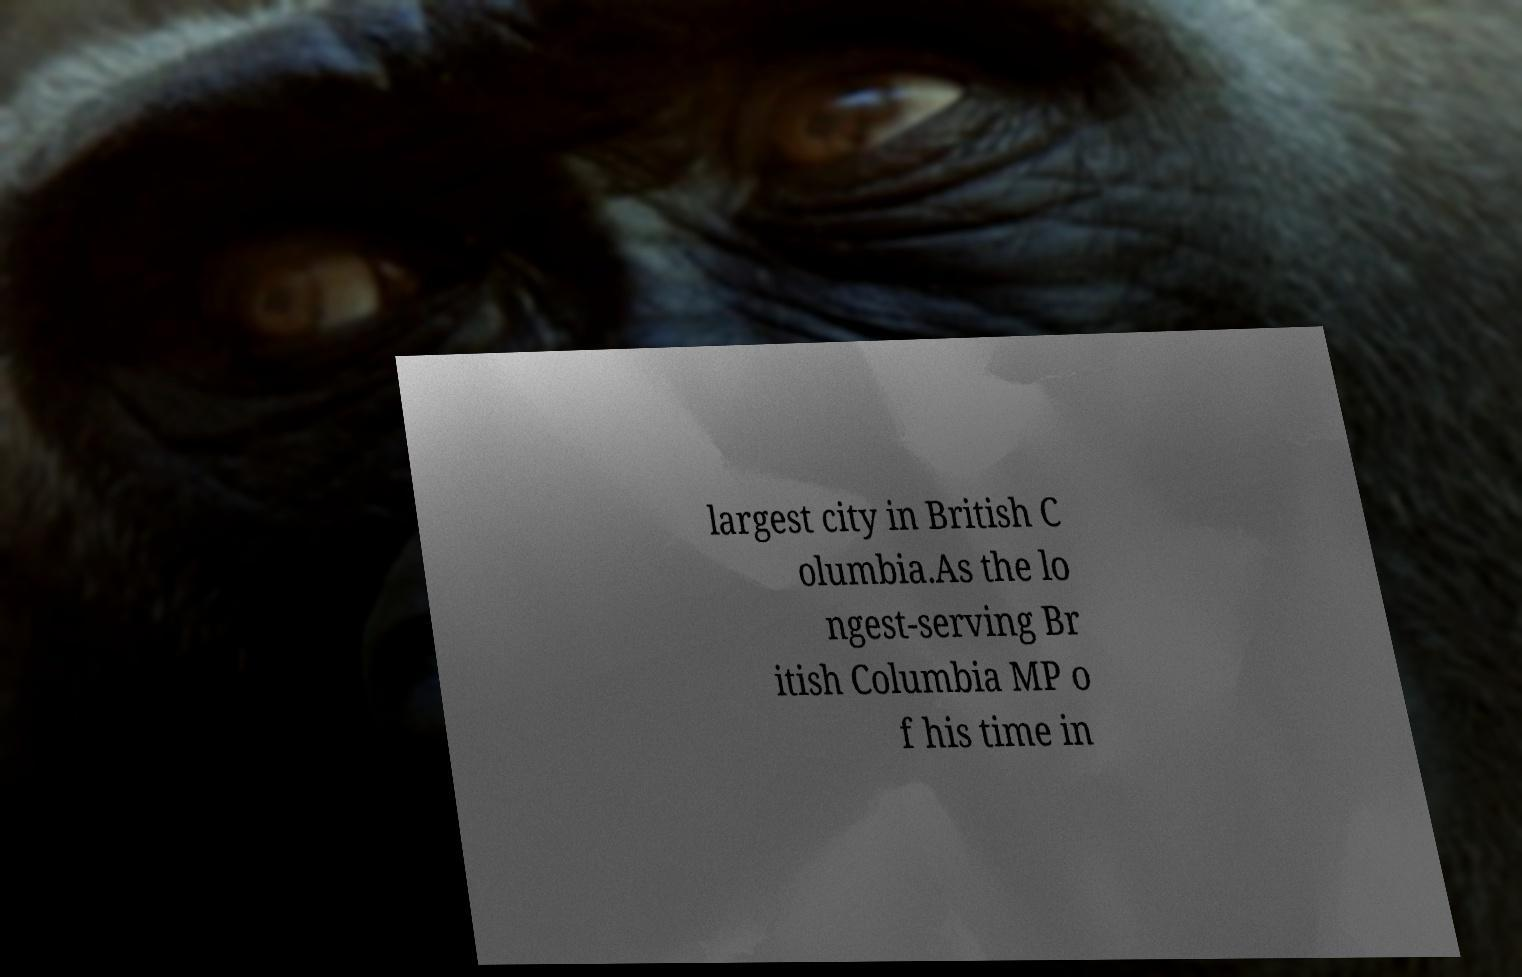Please read and relay the text visible in this image. What does it say? largest city in British C olumbia.As the lo ngest-serving Br itish Columbia MP o f his time in 